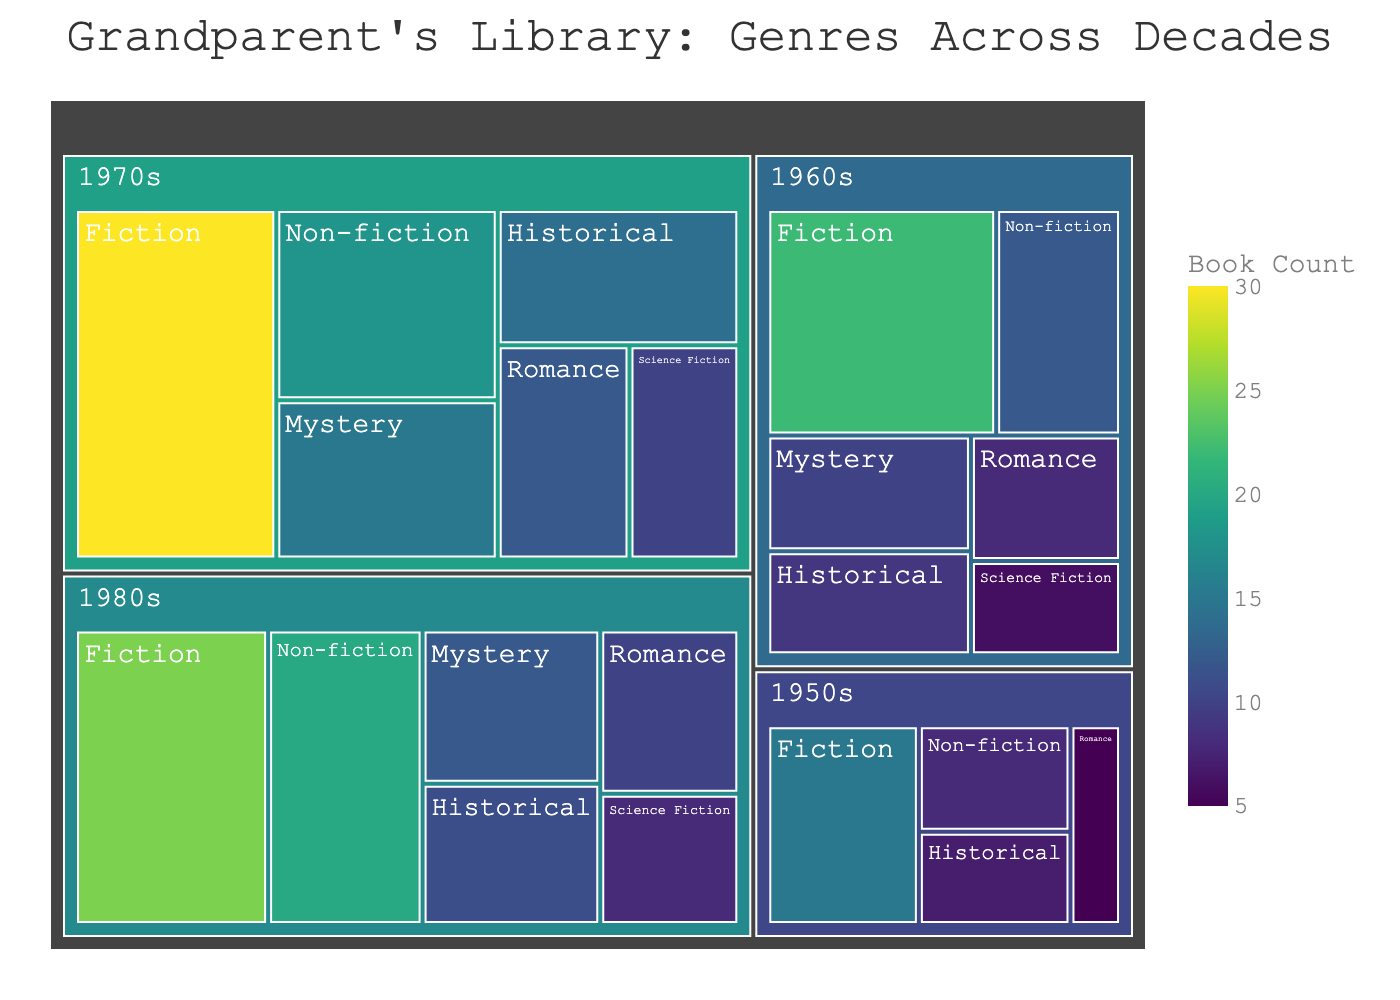Which decade has the highest number of Fiction books? To find this answer, identify the decade section within the Fiction category that has the largest box size, indicating the highest count.
Answer: 1970s What is the total count of books in the 1960s across all genres? To calculate this, sum the counts of the books for each genre in the 1960s: 22 (Fiction) + 12 (Non-fiction) + 10 (Mystery) + 8 (Romance) + 6 (Science Fiction) + 9 (Historical) = 67 books.
Answer: 67 How does the count of Mystery books in the 1970s compare to the 1980s? Look at the tiles for Mystery in the 1970s and 1980s and compare their sizes and counts. There are 15 Mystery books in the 1970s and 12 in the 1980s, so there are more Mystery books in the 1970s.
Answer: More in the 1970s What genre has the least number of books in the 1950s? Locate the decade section for the 1950s and identify the smallest tile among the genres. Romance has the smallest count with 5 books.
Answer: Romance Which decade has the most diverse set of genres? Examine the number of different genre tiles within each decade section. The 1960s, 1970s, and 1980s each have six genres, but only the 1960s and 1970s have equal genre representation, while 1970s also has higher overall counts.
Answer: 1970s What is the total number of books in the Fiction genre across all decades? Add up the counts for all decades in the Fiction category: 15 (1950s) + 22 (1960s) + 30 (1970s) + 25 (1980s) = 92 books.
Answer: 92 How many more Non-fiction books are there in the 1980s compared to the 1950s? Subtract the count of Non-fiction books in the 1950s from the count in the 1980s: 20 (1980s) - 8 (1950s) = 12 more books.
Answer: 12 more books Which decade has the fewest overall books? Add the counts of all genres in each decade and compare: 1950s (15+8+5+7 = 35), 1960s (22+12+10+8+6+9 = 67), 1970s (30+18+15+12+10+14 = 99), 1980s (25+20+12+10+8+11 = 86). The 1950s have the fewest books with 35.
Answer: 1950s 